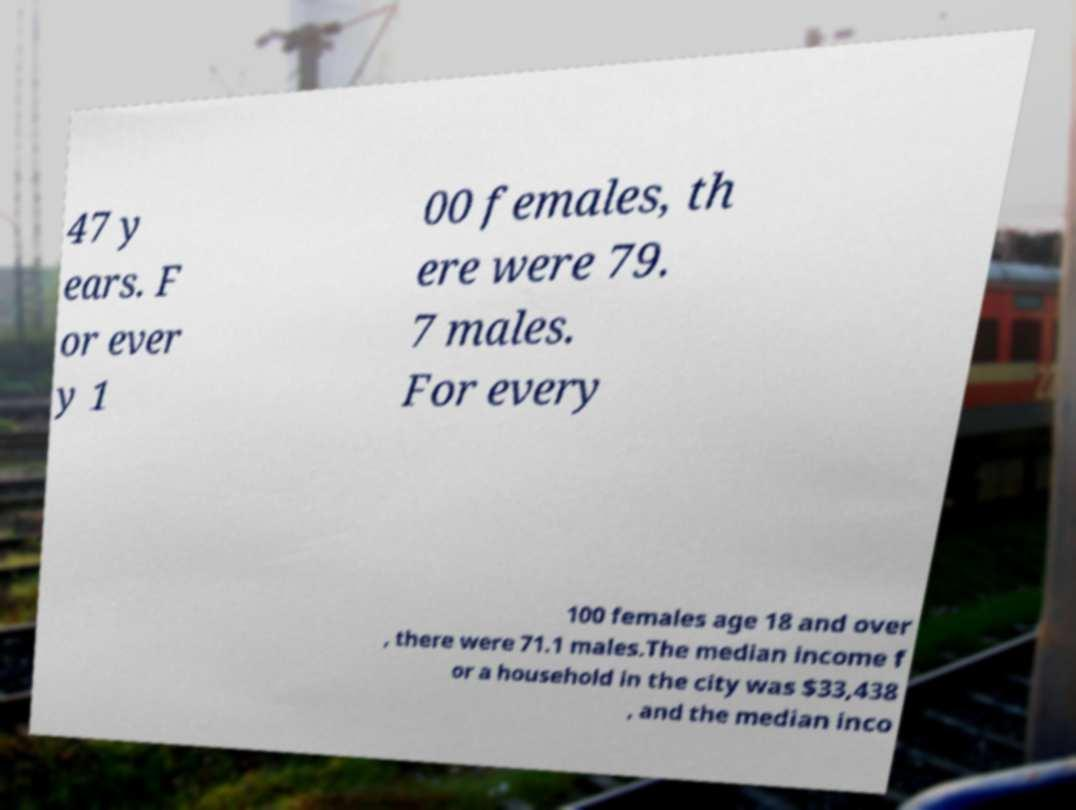Please identify and transcribe the text found in this image. 47 y ears. F or ever y 1 00 females, th ere were 79. 7 males. For every 100 females age 18 and over , there were 71.1 males.The median income f or a household in the city was $33,438 , and the median inco 